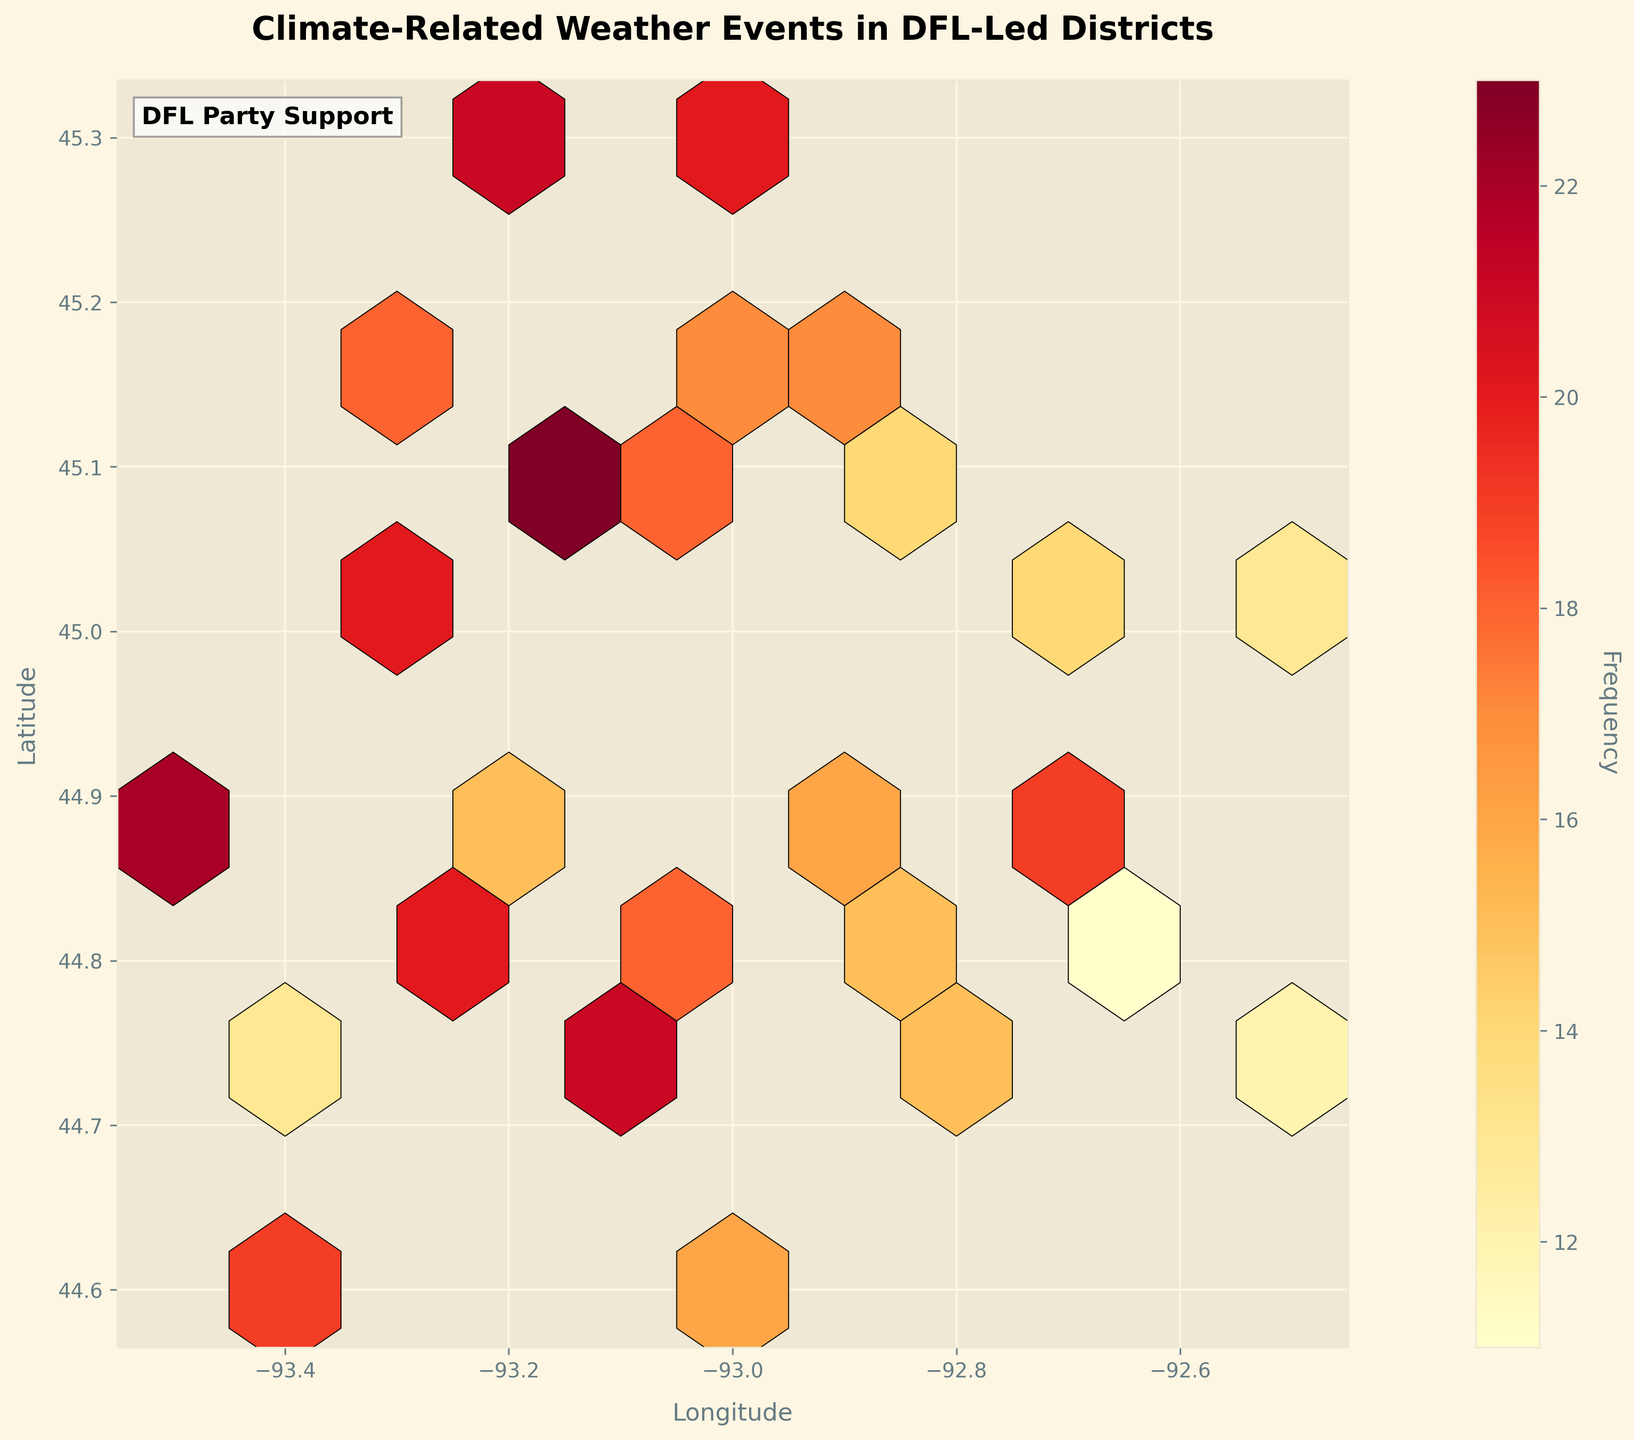What does the color of the hexagons represent? The color of the hexagons indicates the frequency of climate-related weather events in that area, according to the color scale. Lighter colors represent lower frequencies, while darker colors represent higher frequencies.
Answer: Frequency of climate-related weather events What are the latitude and longitude ranges covered in this plot? The latitude values range from approximately 44.6 to 45.3, and the longitude values range from approximately -93.5 to -92.5. This is evident from the x-axis (longitude) and y-axis (latitude) labels and ticks.
Answer: Latitude: 44.6 to 45.3, Longitude: -93.5 to -92.5 Which area appears to have the highest frequency of climate-related weather events? The hexagon with the darkest color indicates the highest frequency of climate-related weather events. From the plot, it's located around the coordinates (approximately) longitude -93.2 and latitude 45.1.
Answer: Around -93.2 longitude and 45.1 latitude Do more events occur at a longitude of -93.1 or at a longitude of -92.8? By comparing the hexagons at -93.1 and -92.8 longitudes, the hexagons around -93.1 generally have darker shades, indicating a higher frequency of events.
Answer: -93.1 What can you deduce if the hex bins have more darker colors and are densely packed? If the hex bins are darker and densely packed, it indicates that the area experienced a high frequency of climate-related weather events.
Answer: High frequency of events How does the frequency of events at latitude 44.8 compare to those at latitude 45.2? The hexagons around latitude 45.2 generally have a darker shade compared to those around latitude 44.8, indicating a higher frequency of events at 45.2.
Answer: Higher at 45.2 What information does the color bar provide? The color bar on the right side of the plot provides a legend for the frequency of events, showing how different shades correspond to different frequency values.
Answer: Frequency legend How many hexagons represent a frequency higher than 20? By examining the hexagons and comparing their shades to the color bar, we can see there are at least two hexagons (one around -93.2, 45.3 and another around -93.2, 45.1) that represent frequencies higher than 20.
Answer: At least two hexagons What does the text "DFL Party Support" indicate on the plot? The text "DFL Party Support" on the bottom left corner of the plot signifies that the data is related to districts led by the DFL Party.
Answer: Data is related to DFL-led districts What is the significance of grid size in a hexbin plot, and what is it set to in this plot? The grid size in a hexbin plot determines the number of hexagons used to display the data. A smaller grid size leads to fewer, larger hexagons, while a larger grid size leads to more, smaller hexagons. In this plot, the grid size is set to 10.
Answer: Grid size is 10 